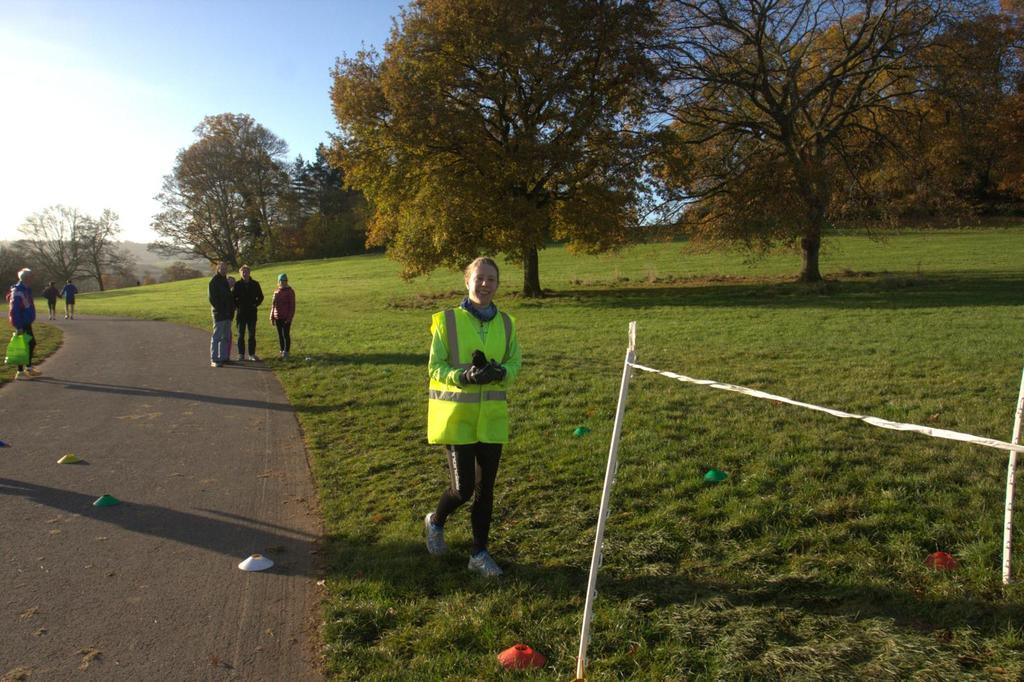How would you summarize this image in a sentence or two? In this image we can see a few people, among them some are holding the objects, there are trees, grass and some other objects, in the background, we can see the sky. 